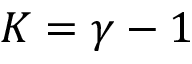Convert formula to latex. <formula><loc_0><loc_0><loc_500><loc_500>K = \gamma - 1</formula> 